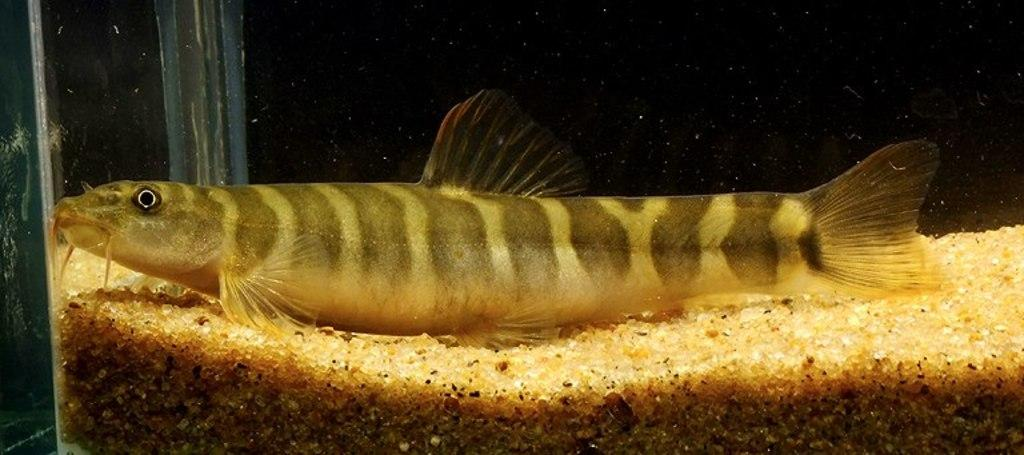What type of animal is present in the image? There is a fish in the image. What can be seen at the bottom of the image? There are stones at the bottom of the image. What might the image be depicting? The image appears to be an aquarium. How many chairs are visible in the image? There are no chairs present in the image. What type of playground equipment can be seen in the image? There is no playground equipment present in the image. 